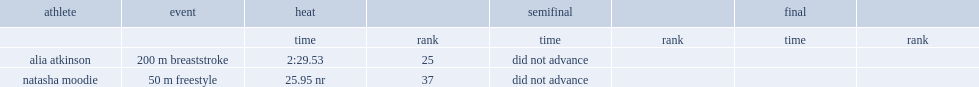What is the final resut for atkinson completing the 200 m breaststroke? 2:29.53. 